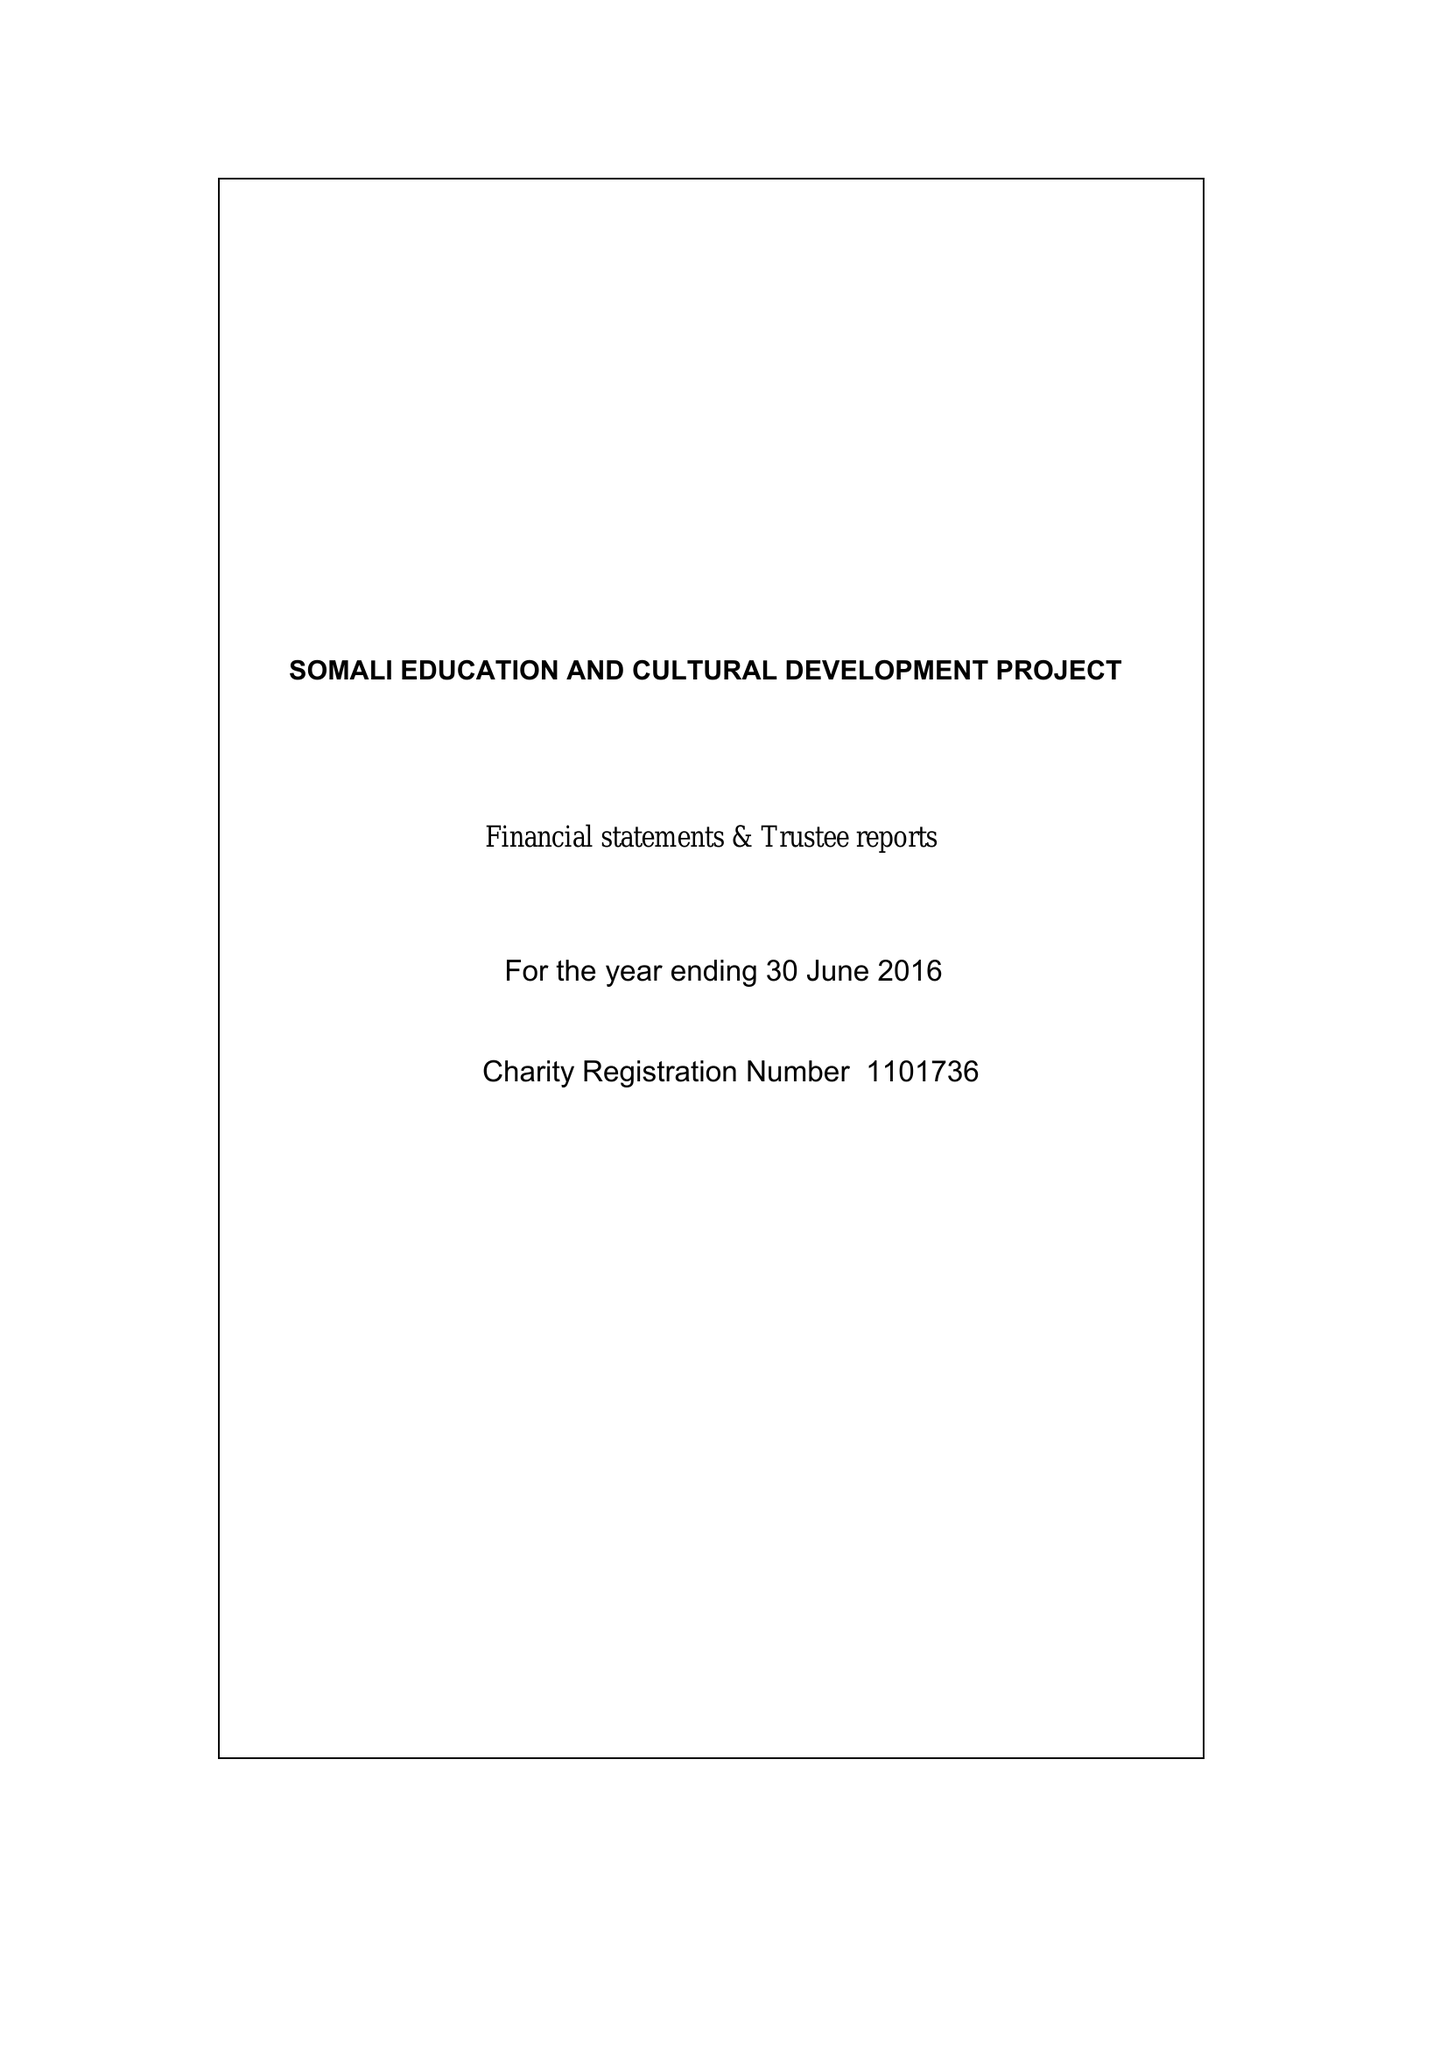What is the value for the address__street_line?
Answer the question using a single word or phrase. 97 EGLINTON HILL 